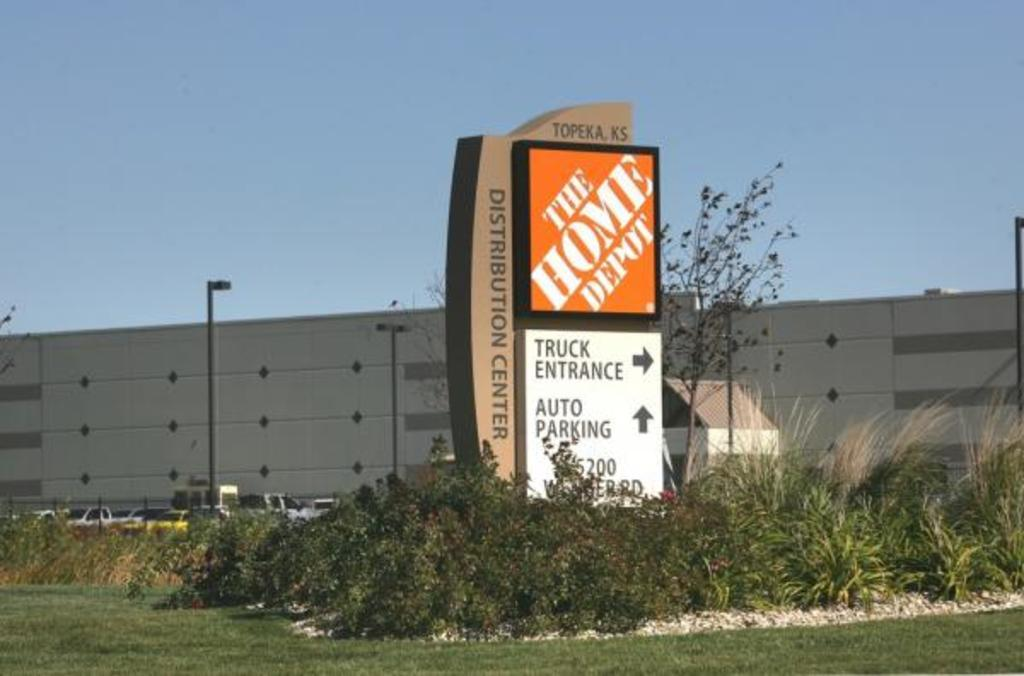What can be seen on the boards in the image? There are boards with text in the image. What type of objects are visible in the image besides the boards? There are vehicles, plants, trees, a wall, and poles in the image. What is visible in the background of the image? The sky is visible in the background of the image. What type of finger can be seen pointing at the vehicles in the image? There are no fingers visible in the image pointing at the vehicles. 